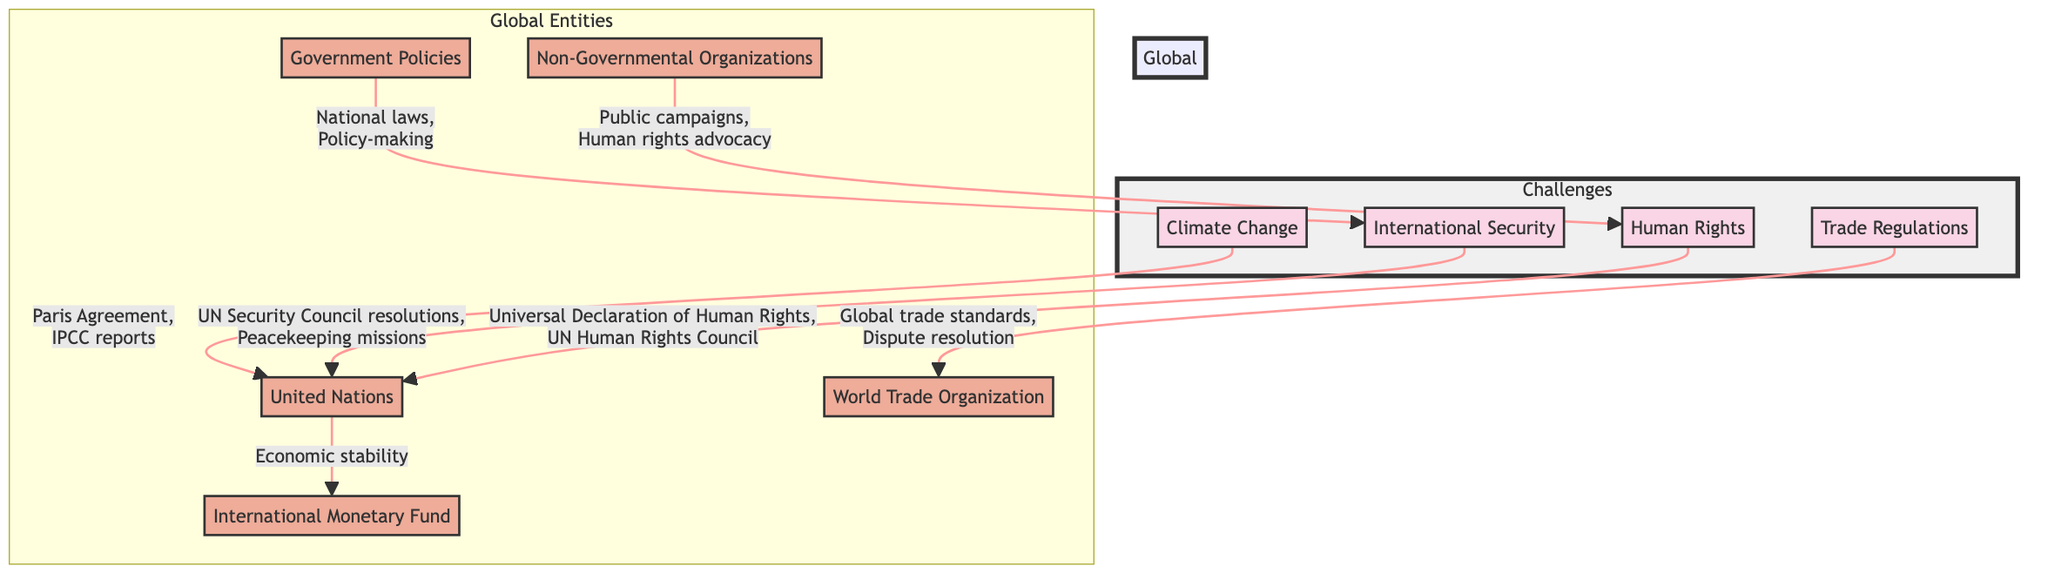What global entity addresses climate change? The diagram indicates that the United Nations is the global entity that addresses climate change through the Paris Agreement and IPCC reports.
Answer: United Nations What are the two key goals for international security mentioned in the diagram? The diagram highlights that the United Nations addresses international security through Security Council resolutions and Peacekeeping missions.
Answer: Security Council resolutions, Peacekeeping missions How many challenges are represented in the diagram? There are four challenges displayed in the diagram: Climate Change, International Security, Human Rights, and Trade Regulations.
Answer: Four Which global entity provides economic stability? The diagram indicates that the International Monetary Fund provides economic stability as a response to actions taken by the United Nations.
Answer: International Monetary Fund What role do NGOs play in addressing human rights? The diagram shows that Non-Governmental Organizations engage in public campaigns and human rights advocacy to address the challenge of human rights.
Answer: Public campaigns, Human rights advocacy Which challenge has a direct link to the World Trade Organization? The diagram specifically indicates that Trade Regulations are connected to the World Trade Organization through aspects like global trade standards and dispute resolution.
Answer: Trade Regulations What is the relationship between government policies and international security? According to the diagram, government policies influence international security by contributing through national laws and policy-making actions.
Answer: National laws, Policy-making How does the United Nations connect to international security and trade regulations? The diagram illustrates that the United Nations addresses international security through resolutions and peacekeeping while also handling trade regulations by working with the World Trade Organization, reflecting interconnectedness between these issues.
Answer: Resolutions, Peacekeeping; Global trade standards, Dispute resolution Which challenge has the most interconnected global entities? The diagram indicates that Human Rights has multiple connections with Non-Governmental Organizations and the United Nations, highlighting its engagement from various entities, but it is primarily linked to the UN.
Answer: Human Rights 